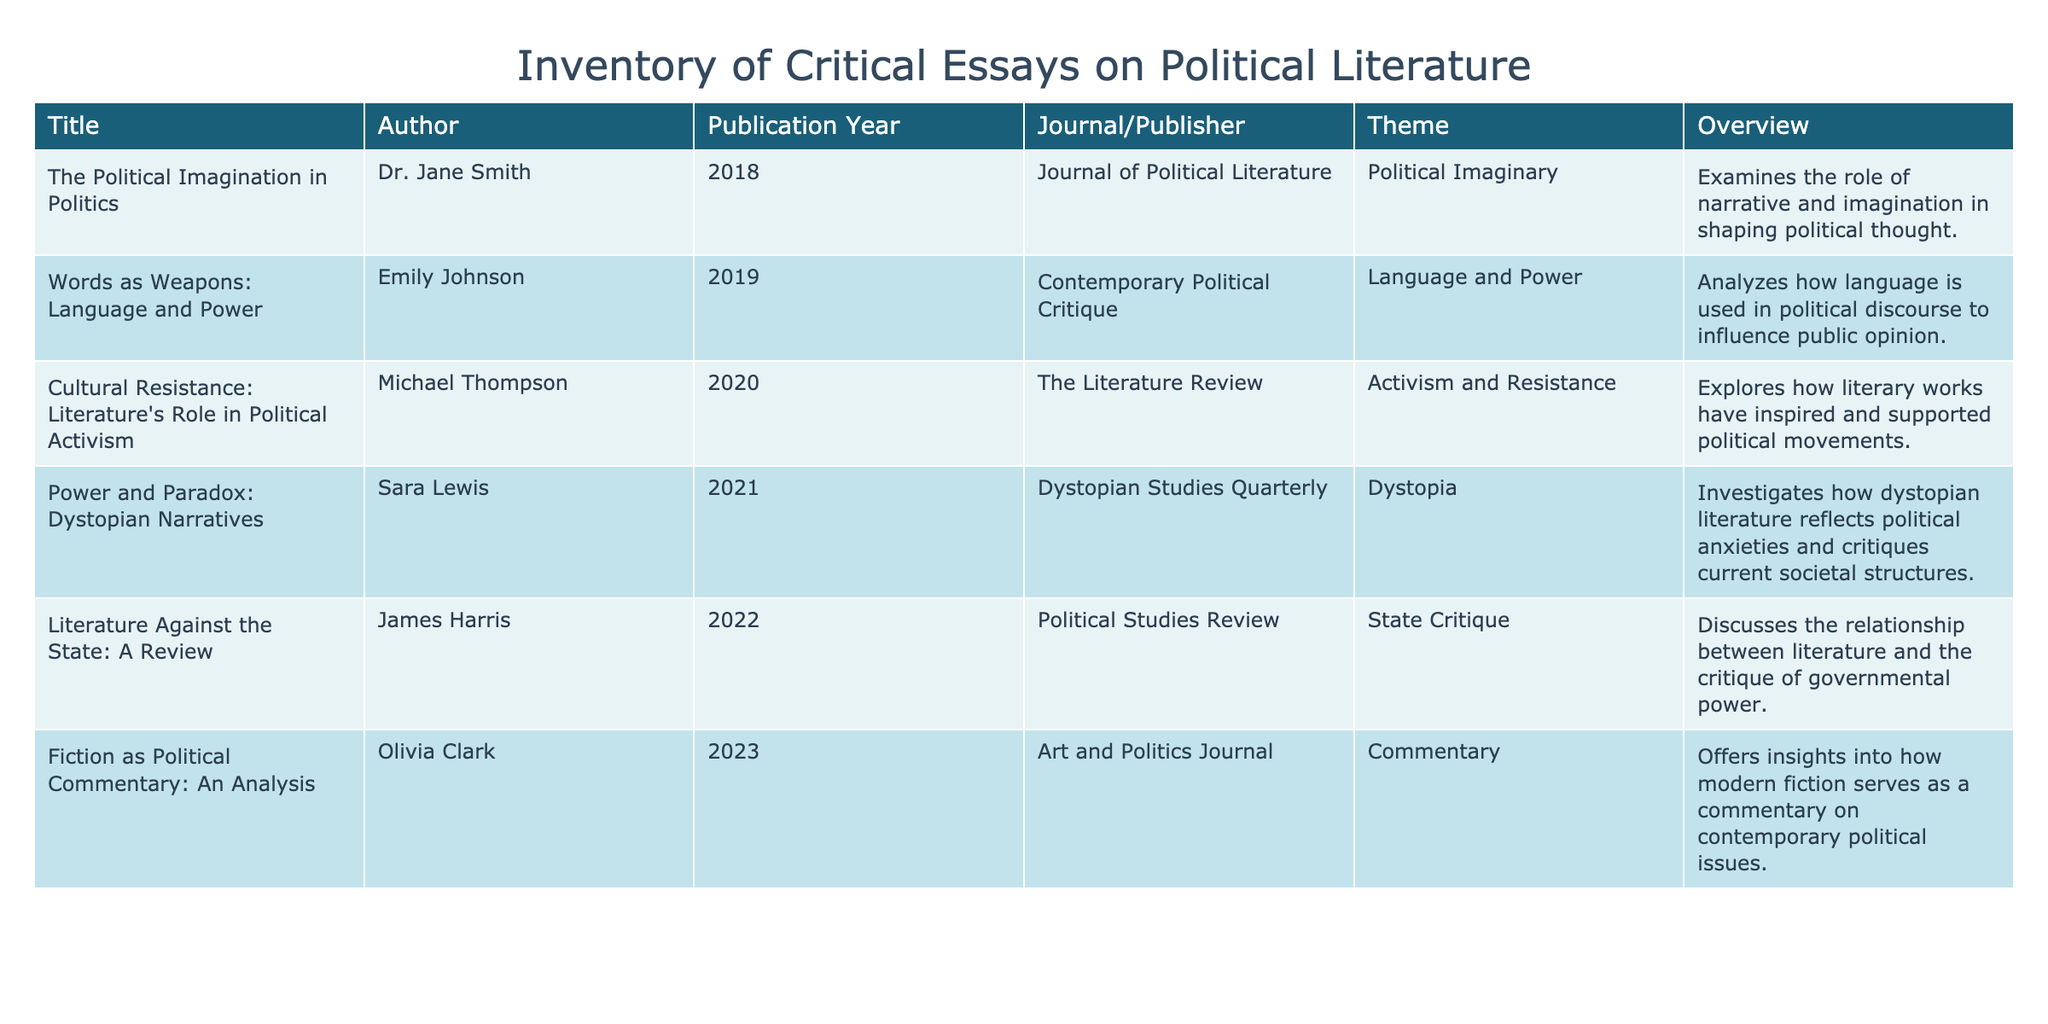What is the publication year of "Words as Weapons: Language and Power"? The title "Words as Weapons: Language and Power" appears in the table, and the corresponding publication year is listed next to it in the 'Publication Year' column. By looking at that specific row, we can see that the publication year is 2019.
Answer: 2019 Who authored the essay titled "Cultural Resistance: Literature's Role in Political Activism"? In the table, the title "Cultural Resistance: Literature's Role in Political Activism" has the author's name listed next to it in the 'Author' column. Referring to that row, we find that the author is Michael Thompson.
Answer: Michael Thompson How many essays were published in the year 2021 or later? We need to count the number of rows where the 'Publication Year' is 2021 or later. Scanning through the table, we find three essays: one from 2021, one from 2022, and another from 2023. Hence, the total count is 3.
Answer: 3 Was "Fiction as Political Commentary: An Analysis" published in the 2020s? To answer this, we check the publication year of "Fiction as Political Commentary: An Analysis." It's listed under the 'Publication Year' column as 2023, which is in the 2020s. Therefore, the answer is yes.
Answer: Yes What themes are discussed in the essays by Michael Thompson and Olivia Clark? We can find the themes by locating the rows for both authors. Michael Thompson's essay's theme is "Activism and Resistance," while Olivia Clark's theme is "Commentary." Thus, these two themes are discussed in their respective essays.
Answer: Activism and Resistance; Commentary What is the difference between the years of publication for "Power and Paradox: Dystopian Narratives" and "Literature Against the State: A Review"? First, we find the publication year of "Power and Paradox: Dystopian Narratives," which is 2021, and compare it to "Literature Against the State: A Review," with the publication year of 2022. The difference is 2022 - 2021 = 1 year.
Answer: 1 year Is any essay published in 2018 related to the theme of State Critique? To answer this, we check the year 2018 in the table. The only essay from that year is "The Political Imagination in Politics," which has a theme of "Political Imaginary." Since there's no essay from 2018 concerning State Critique, the answer is no.
Answer: No How many total themes are represented by the essays listed in the table? We need to identify the different themes presented in the table's 'Theme' column and count them. The themes are: Political Imaginary, Language and Power, Activism and Resistance, Dystopia, State Critique, and Commentary. This gives us 6 unique themes.
Answer: 6 